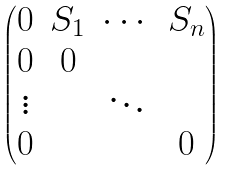Convert formula to latex. <formula><loc_0><loc_0><loc_500><loc_500>\begin{pmatrix} 0 & S _ { 1 } & \cdots & S _ { n } \\ 0 & 0 & & \\ \vdots & & \ddots & \\ 0 & & & 0 \end{pmatrix}</formula> 